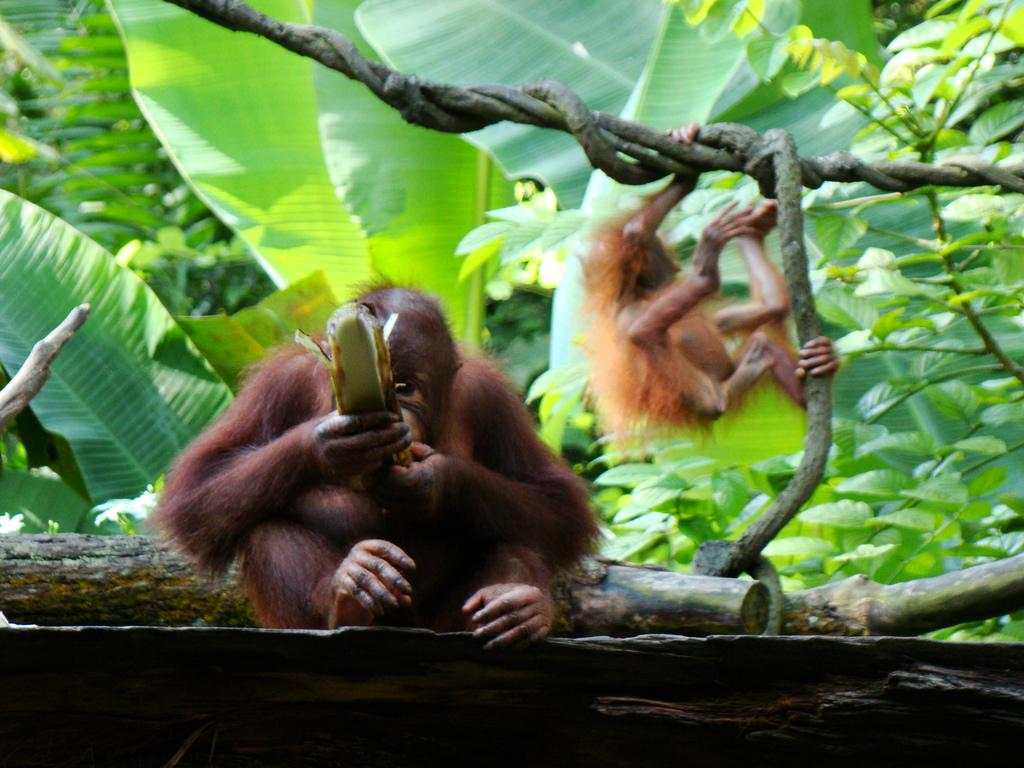What type of animals are present in the image? There are apes in the image. Where are the apes located in the image? The apes are present over a place. What type of vegetation can be seen in the image? There are plants and trees visible in the image. What letter is being held by the apes in the image? There is no letter present in the image; the apes are not holding any objects. 